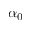<formula> <loc_0><loc_0><loc_500><loc_500>\alpha _ { 0 }</formula> 